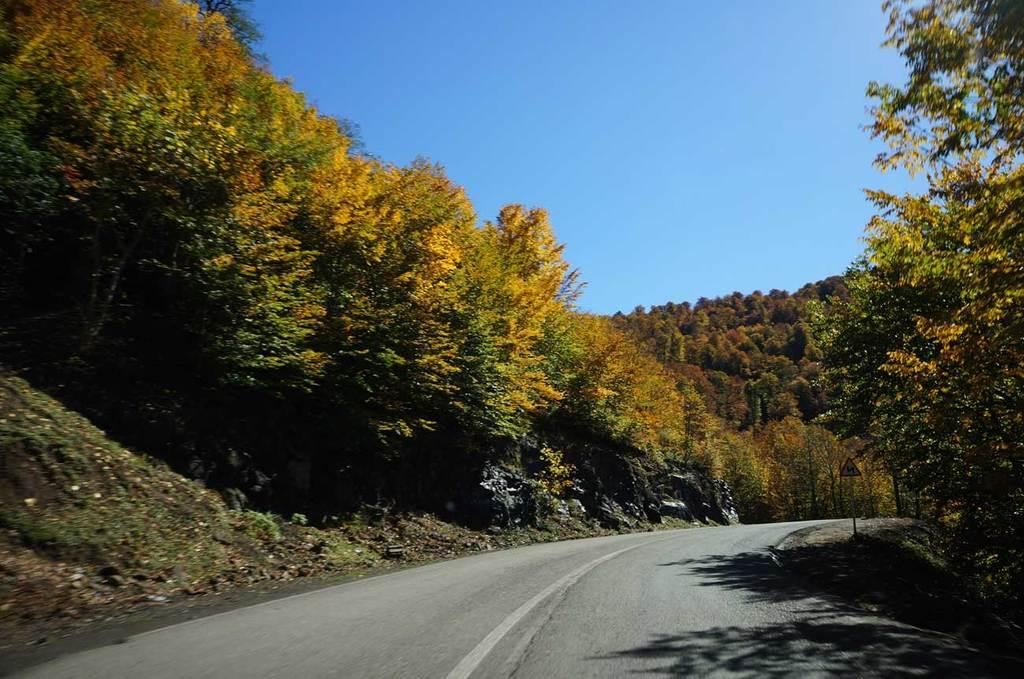What is located in the middle of the image? There is a road in the middle of the image. What type of vegetation is on either side of the road? There are trees on either side of the road. What is the condition of the sky in the image? The sky is visible at the top of the image, and it is sunny. What is the amount of collars visible on the rail in the image? There is no rail or collar present in the image. How many rail tracks are visible in the image? There are no rail tracks visible in the image; it features a road with trees on either side. 